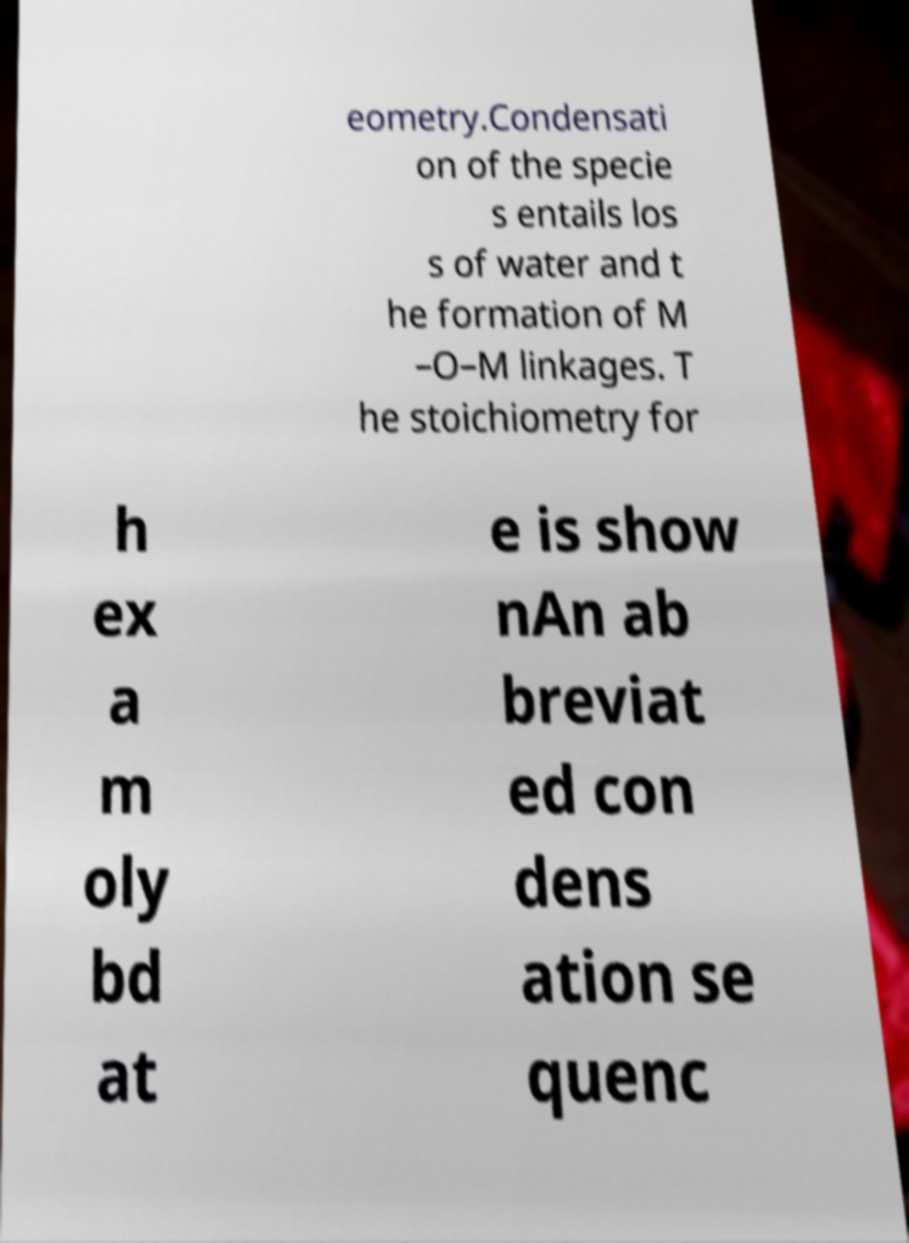Can you accurately transcribe the text from the provided image for me? eometry.Condensati on of the specie s entails los s of water and t he formation of M –O–M linkages. T he stoichiometry for h ex a m oly bd at e is show nAn ab breviat ed con dens ation se quenc 